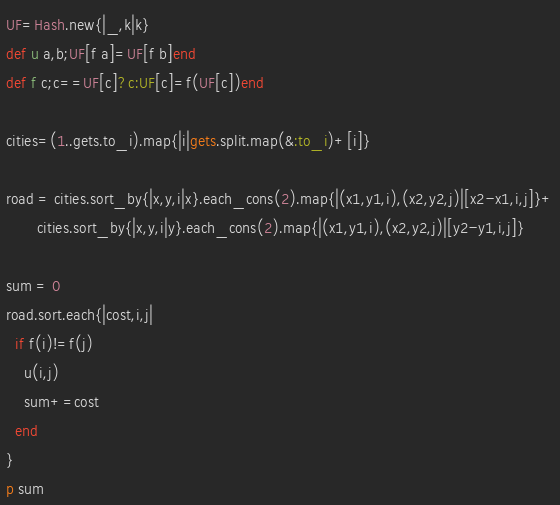<code> <loc_0><loc_0><loc_500><loc_500><_Ruby_>UF=Hash.new{|_,k|k}
def u a,b;UF[f a]=UF[f b]end
def f c;c==UF[c]?c:UF[c]=f(UF[c])end

cities=(1..gets.to_i).map{|i|gets.split.map(&:to_i)+[i]}

road = cities.sort_by{|x,y,i|x}.each_cons(2).map{|(x1,y1,i),(x2,y2,j)|[x2-x1,i,j]}+
       cities.sort_by{|x,y,i|y}.each_cons(2).map{|(x1,y1,i),(x2,y2,j)|[y2-y1,i,j]}

sum = 0
road.sort.each{|cost,i,j|
  if f(i)!=f(j)
    u(i,j)
    sum+=cost
  end
}
p sum</code> 